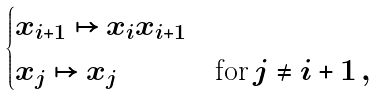Convert formula to latex. <formula><loc_0><loc_0><loc_500><loc_500>\begin{cases} x _ { i + 1 } \mapsto x _ { i } x _ { i + 1 } & \\ x _ { j } \mapsto x _ { j } & \text {for} \, j \neq i + 1 \, , \end{cases}</formula> 